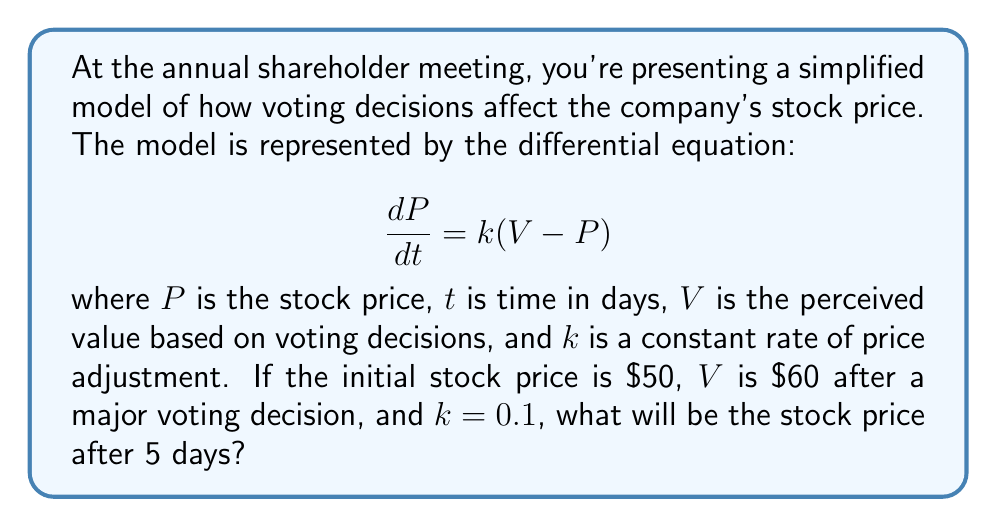Help me with this question. To solve this problem, we need to use the solution to the first-order linear differential equation:

1) The general solution to the equation $\frac{dP}{dt} = k(V - P)$ is:

   $$P(t) = V + (P_0 - V)e^{-kt}$$

   where $P_0$ is the initial stock price.

2) We're given the following values:
   - $P_0 = \$50$ (initial stock price)
   - $V = \$60$ (perceived value after voting)
   - $k = 0.1$ (adjustment rate)
   - $t = 5$ (days)

3) Substituting these values into the solution:

   $$P(5) = 60 + (50 - 60)e^{-0.1(5)}$$

4) Simplify:
   $$P(5) = 60 - 10e^{-0.5}$$

5) Calculate $e^{-0.5} \approx 0.6065$:

   $$P(5) = 60 - 10(0.6065) = 60 - 6.065 = 53.935$$

6) Round to two decimal places:

   $$P(5) \approx \$53.94$$
Answer: $\$53.94 